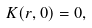Convert formula to latex. <formula><loc_0><loc_0><loc_500><loc_500>K ( r , 0 ) = 0 ,</formula> 